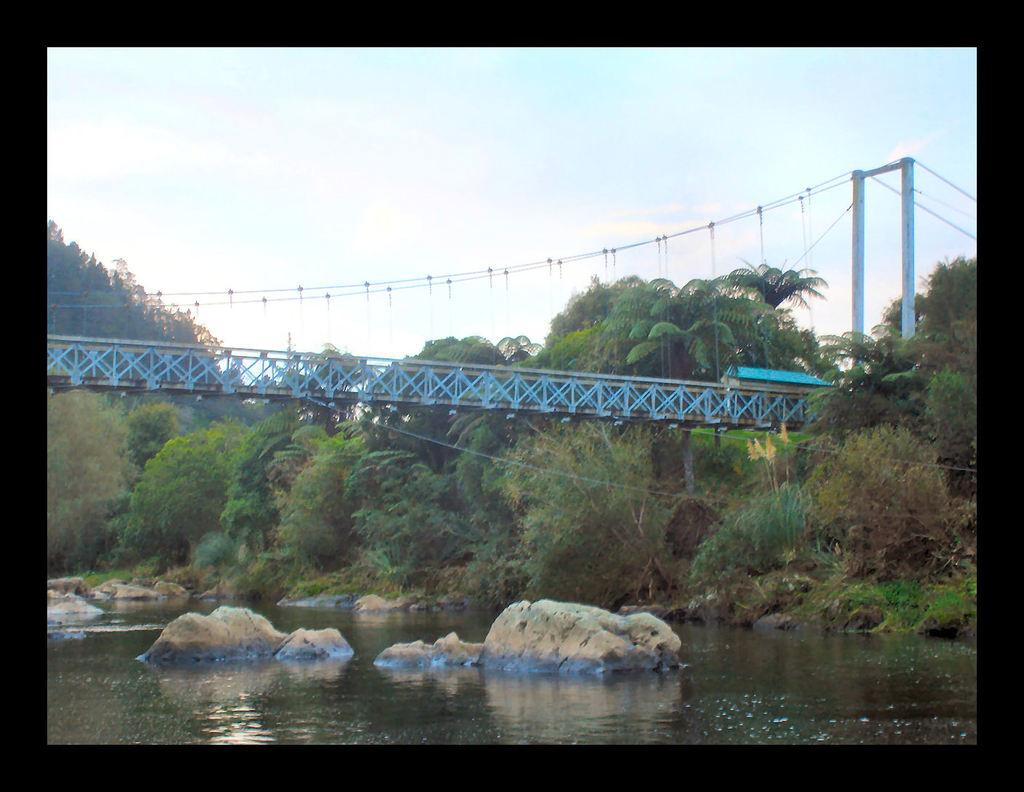What structure is located in the middle of the image? There is a bridge in the middle of the image. What else can be seen in the middle of the image besides the bridge? There are trees in the middle of the image. What is visible at the bottom of the image? Water is visible at the bottom of the image. What is visible at the top of the image? The sky is visible at the top of the image. How many sheep are visible in the image? There are no sheep present in the image. What type of expansion is occurring in the image? There is no expansion visible in the image. 